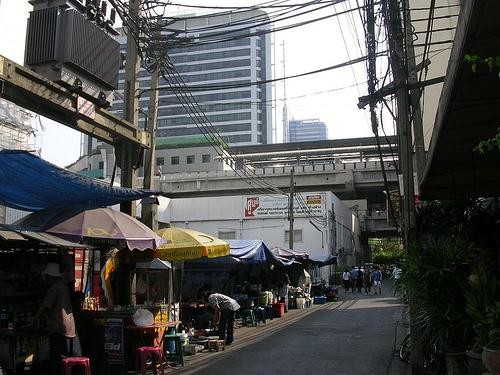Why are there tarps and umbrellas? Please explain your reasoning. market. To give people protection from sun and rain while they shop or eat. 